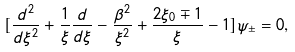Convert formula to latex. <formula><loc_0><loc_0><loc_500><loc_500>[ \frac { d ^ { 2 } } { d \xi ^ { 2 } } + \frac { 1 } { \xi } \frac { d } { d \xi } - \frac { \beta ^ { 2 } } { \xi ^ { 2 } } + \frac { 2 \xi _ { 0 } \mp 1 } { \xi } - 1 ] \psi _ { \pm } = 0 ,</formula> 